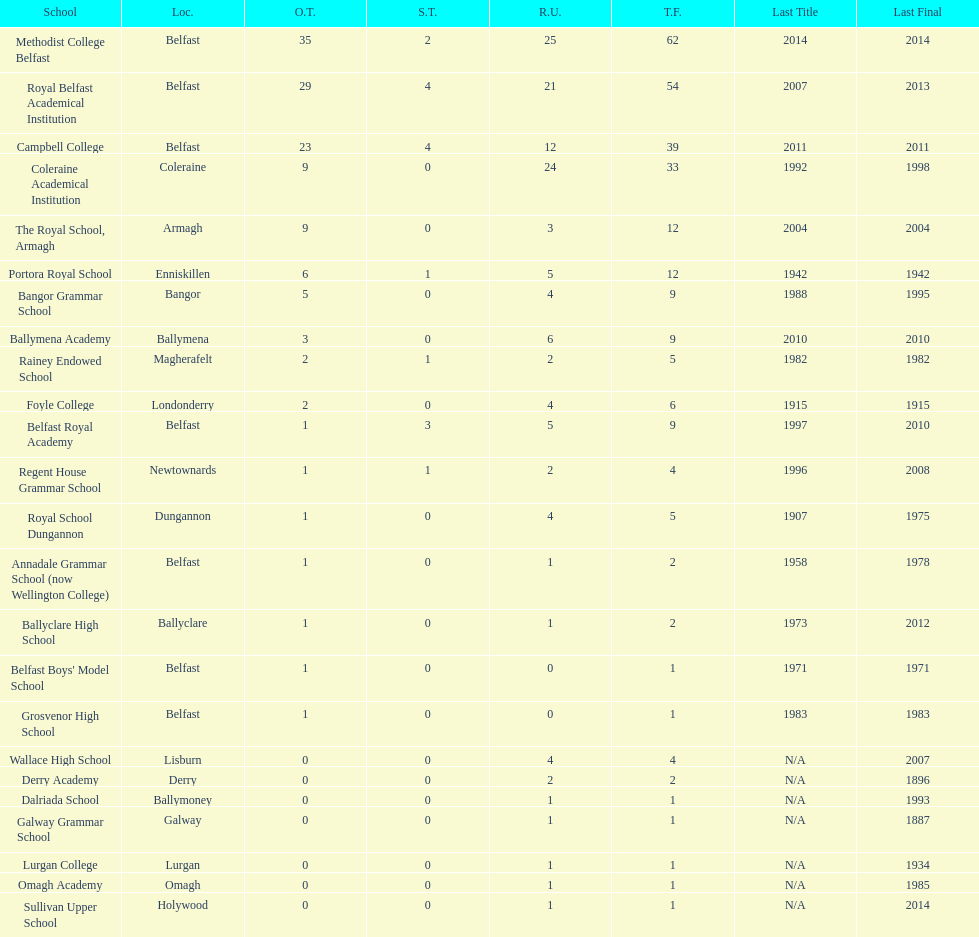How many schools have had at least 3 share titles? 3. 